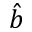Convert formula to latex. <formula><loc_0><loc_0><loc_500><loc_500>\hat { b }</formula> 